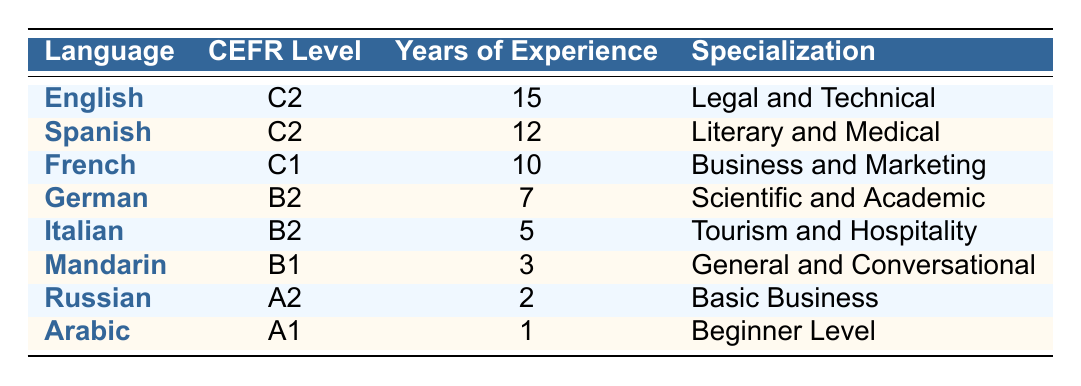What is the CEFR level of Spanish? According to the table, Spanish has a CEFR level of C2.
Answer: C2 How many years of experience does the translator have in Italian? The table shows that the translator has 5 years of experience in Italian.
Answer: 5 Is the specialization for Russian primarily in Basic Business? Yes, the table indicates that the specialization for Russian is Basic Business.
Answer: Yes Which language has the highest years of experience listed? By comparing the years of experience for all languages, English has the highest with 15 years.
Answer: English What is the average CEFR level for all languages listed in the table? The CEFR levels can be approximated as A1=1, A2=2, B1=3, B2=4, C1=5, and C2=6. The levels correspond to: English (6), Spanish (6), French (5), German (4), Italian (4), Mandarin (3), Russian (2), and Arabic (1). The total is 31, and there are 8 languages. So, the average is 31/8 = 3.875, which is approximately B1 level.
Answer: B1 Which language has the lowest years of experience and what is that level? Arabic has the lowest years of experience at 1 year, with a CEFR level of A1.
Answer: Arabic, A1 How many languages have a CEFR level of C2? The table shows that there are 2 languages with a CEFR level of C2: English and Spanish.
Answer: 2 If we combine the years of experience in Italian and Mandarin, how many years do we have in total? The years of experience for Italian is 5, and for Mandarin, it is 3. Adding these, 5 + 3 equals 8 years.
Answer: 8 Is there any language that has a specialization in Legal and Technical? Yes, the table indicates that English has a specialization in Legal and Technical.
Answer: Yes 